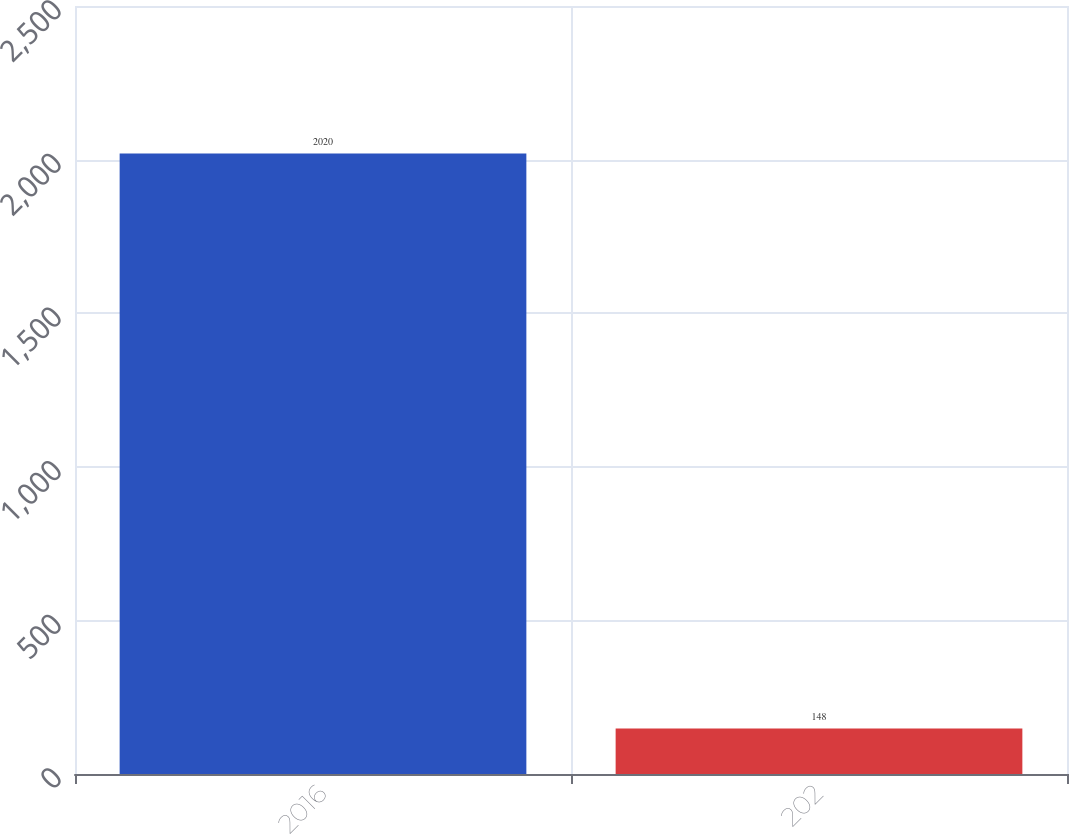Convert chart. <chart><loc_0><loc_0><loc_500><loc_500><bar_chart><fcel>2016<fcel>202<nl><fcel>2020<fcel>148<nl></chart> 